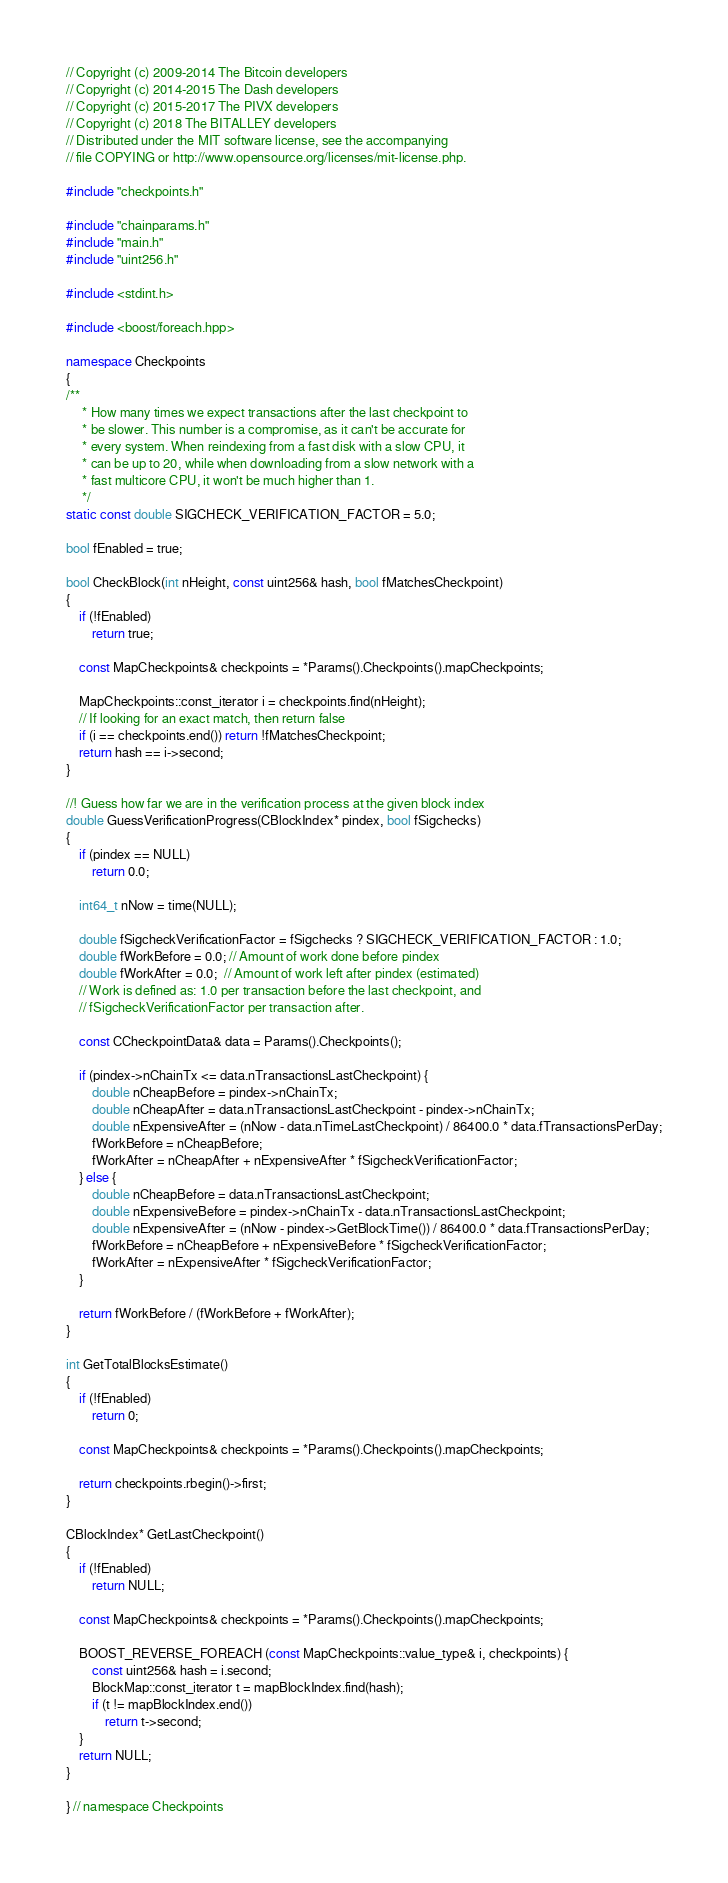Convert code to text. <code><loc_0><loc_0><loc_500><loc_500><_C++_>// Copyright (c) 2009-2014 The Bitcoin developers
// Copyright (c) 2014-2015 The Dash developers
// Copyright (c) 2015-2017 The PIVX developers
// Copyright (c) 2018 The BITALLEY developers
// Distributed under the MIT software license, see the accompanying
// file COPYING or http://www.opensource.org/licenses/mit-license.php.

#include "checkpoints.h"

#include "chainparams.h"
#include "main.h"
#include "uint256.h"

#include <stdint.h>

#include <boost/foreach.hpp>

namespace Checkpoints
{
/**
     * How many times we expect transactions after the last checkpoint to
     * be slower. This number is a compromise, as it can't be accurate for
     * every system. When reindexing from a fast disk with a slow CPU, it
     * can be up to 20, while when downloading from a slow network with a
     * fast multicore CPU, it won't be much higher than 1.
     */
static const double SIGCHECK_VERIFICATION_FACTOR = 5.0;

bool fEnabled = true;

bool CheckBlock(int nHeight, const uint256& hash, bool fMatchesCheckpoint)
{
    if (!fEnabled)
        return true;

    const MapCheckpoints& checkpoints = *Params().Checkpoints().mapCheckpoints;

    MapCheckpoints::const_iterator i = checkpoints.find(nHeight);
    // If looking for an exact match, then return false
    if (i == checkpoints.end()) return !fMatchesCheckpoint;
    return hash == i->second;
}

//! Guess how far we are in the verification process at the given block index
double GuessVerificationProgress(CBlockIndex* pindex, bool fSigchecks)
{
    if (pindex == NULL)
        return 0.0;

    int64_t nNow = time(NULL);

    double fSigcheckVerificationFactor = fSigchecks ? SIGCHECK_VERIFICATION_FACTOR : 1.0;
    double fWorkBefore = 0.0; // Amount of work done before pindex
    double fWorkAfter = 0.0;  // Amount of work left after pindex (estimated)
    // Work is defined as: 1.0 per transaction before the last checkpoint, and
    // fSigcheckVerificationFactor per transaction after.

    const CCheckpointData& data = Params().Checkpoints();

    if (pindex->nChainTx <= data.nTransactionsLastCheckpoint) {
        double nCheapBefore = pindex->nChainTx;
        double nCheapAfter = data.nTransactionsLastCheckpoint - pindex->nChainTx;
        double nExpensiveAfter = (nNow - data.nTimeLastCheckpoint) / 86400.0 * data.fTransactionsPerDay;
        fWorkBefore = nCheapBefore;
        fWorkAfter = nCheapAfter + nExpensiveAfter * fSigcheckVerificationFactor;
    } else {
        double nCheapBefore = data.nTransactionsLastCheckpoint;
        double nExpensiveBefore = pindex->nChainTx - data.nTransactionsLastCheckpoint;
        double nExpensiveAfter = (nNow - pindex->GetBlockTime()) / 86400.0 * data.fTransactionsPerDay;
        fWorkBefore = nCheapBefore + nExpensiveBefore * fSigcheckVerificationFactor;
        fWorkAfter = nExpensiveAfter * fSigcheckVerificationFactor;
    }

    return fWorkBefore / (fWorkBefore + fWorkAfter);
}

int GetTotalBlocksEstimate()
{
    if (!fEnabled)
        return 0;

    const MapCheckpoints& checkpoints = *Params().Checkpoints().mapCheckpoints;

    return checkpoints.rbegin()->first;
}

CBlockIndex* GetLastCheckpoint()
{
    if (!fEnabled)
        return NULL;

    const MapCheckpoints& checkpoints = *Params().Checkpoints().mapCheckpoints;

    BOOST_REVERSE_FOREACH (const MapCheckpoints::value_type& i, checkpoints) {
        const uint256& hash = i.second;
        BlockMap::const_iterator t = mapBlockIndex.find(hash);
        if (t != mapBlockIndex.end())
            return t->second;
    }
    return NULL;
}

} // namespace Checkpoints
</code> 